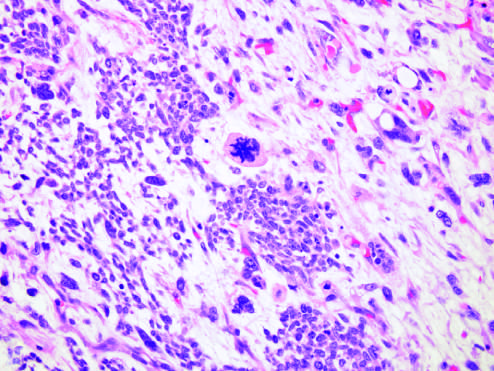was focal anaplasia present in other areas within this wilms tumor, characterized by cells with hyperchromatic, pleomorphic nuclei, and an abnormal mitosis center of field?
Answer the question using a single word or phrase. Yes 